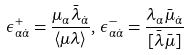<formula> <loc_0><loc_0><loc_500><loc_500>\epsilon ^ { + } _ { \alpha \dot { \alpha } } = \frac { \mu _ { \alpha } \bar { \lambda } _ { \dot { \alpha } } } { \langle \mu \lambda \rangle } , \, \epsilon ^ { - } _ { \alpha \dot { \alpha } } = \frac { \lambda _ { \alpha } \bar { \mu } _ { \dot { \alpha } } } { [ \bar { \lambda } \bar { \mu } ] }</formula> 